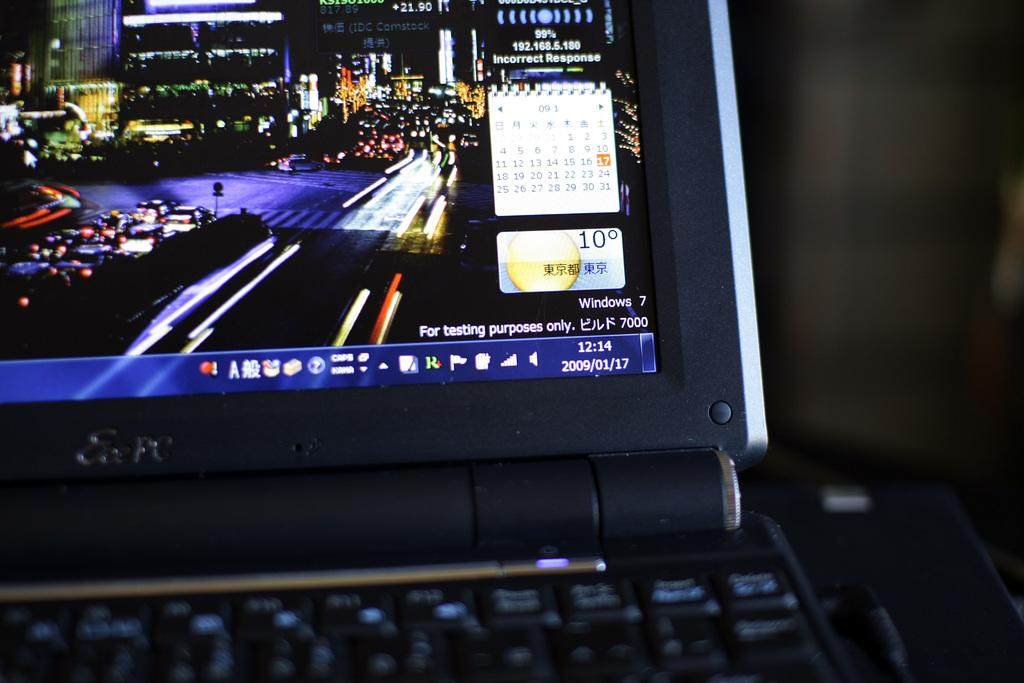Provide a one-sentence caption for the provided image. The corner of a laptop screen running Windows 7 for testing purposes only. 